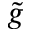Convert formula to latex. <formula><loc_0><loc_0><loc_500><loc_500>\tilde { g }</formula> 